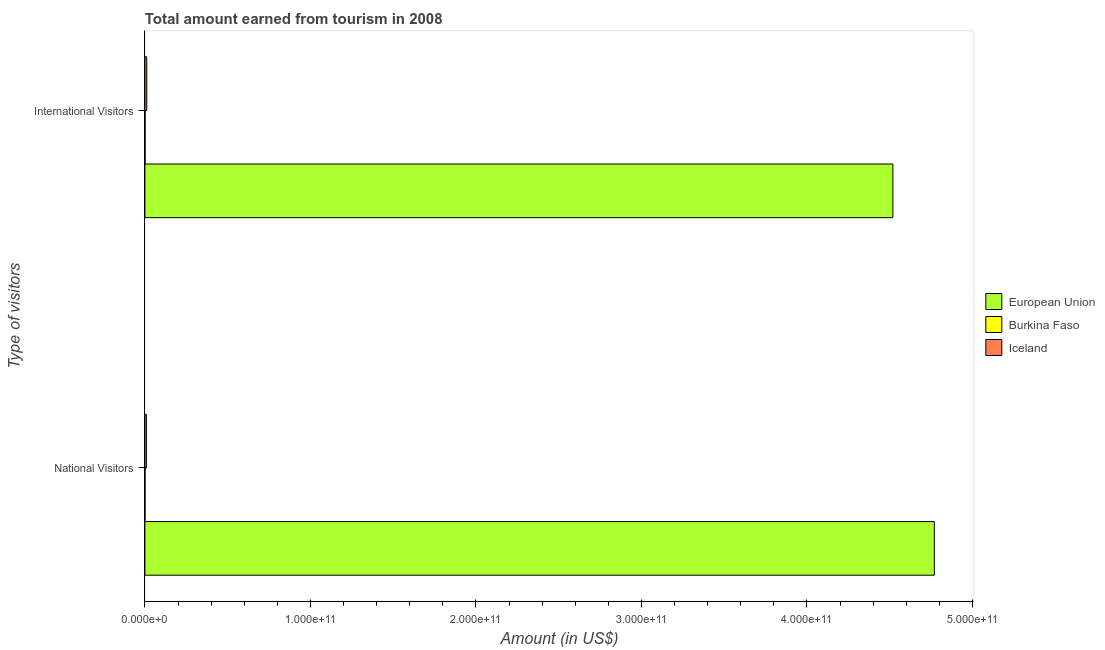Are the number of bars on each tick of the Y-axis equal?
Your response must be concise. Yes. What is the label of the 1st group of bars from the top?
Make the answer very short. International Visitors. What is the amount earned from international visitors in Burkina Faso?
Your response must be concise. 1.10e+08. Across all countries, what is the maximum amount earned from national visitors?
Keep it short and to the point. 4.77e+11. Across all countries, what is the minimum amount earned from international visitors?
Ensure brevity in your answer.  1.10e+08. In which country was the amount earned from national visitors maximum?
Offer a terse response. European Union. In which country was the amount earned from national visitors minimum?
Provide a succinct answer. Burkina Faso. What is the total amount earned from international visitors in the graph?
Your response must be concise. 4.53e+11. What is the difference between the amount earned from national visitors in European Union and that in Iceland?
Your answer should be compact. 4.76e+11. What is the difference between the amount earned from national visitors in European Union and the amount earned from international visitors in Burkina Faso?
Provide a succinct answer. 4.77e+11. What is the average amount earned from national visitors per country?
Give a very brief answer. 1.59e+11. What is the difference between the amount earned from national visitors and amount earned from international visitors in Iceland?
Your answer should be very brief. -2.22e+08. In how many countries, is the amount earned from international visitors greater than 320000000000 US$?
Offer a terse response. 1. What is the ratio of the amount earned from international visitors in Burkina Faso to that in European Union?
Offer a very short reply. 0. In how many countries, is the amount earned from international visitors greater than the average amount earned from international visitors taken over all countries?
Provide a short and direct response. 1. What does the 2nd bar from the top in International Visitors represents?
Provide a short and direct response. Burkina Faso. What does the 3rd bar from the bottom in National Visitors represents?
Offer a very short reply. Iceland. How many bars are there?
Keep it short and to the point. 6. How many countries are there in the graph?
Make the answer very short. 3. What is the difference between two consecutive major ticks on the X-axis?
Your answer should be very brief. 1.00e+11. Does the graph contain any zero values?
Offer a terse response. No. Where does the legend appear in the graph?
Provide a short and direct response. Center right. What is the title of the graph?
Make the answer very short. Total amount earned from tourism in 2008. What is the label or title of the Y-axis?
Provide a short and direct response. Type of visitors. What is the Amount (in US$) of European Union in National Visitors?
Ensure brevity in your answer.  4.77e+11. What is the Amount (in US$) in Burkina Faso in National Visitors?
Your answer should be very brief. 8.20e+07. What is the Amount (in US$) of Iceland in National Visitors?
Provide a succinct answer. 8.81e+08. What is the Amount (in US$) of European Union in International Visitors?
Ensure brevity in your answer.  4.52e+11. What is the Amount (in US$) of Burkina Faso in International Visitors?
Provide a succinct answer. 1.10e+08. What is the Amount (in US$) in Iceland in International Visitors?
Provide a succinct answer. 1.10e+09. Across all Type of visitors, what is the maximum Amount (in US$) in European Union?
Give a very brief answer. 4.77e+11. Across all Type of visitors, what is the maximum Amount (in US$) of Burkina Faso?
Offer a very short reply. 1.10e+08. Across all Type of visitors, what is the maximum Amount (in US$) in Iceland?
Provide a succinct answer. 1.10e+09. Across all Type of visitors, what is the minimum Amount (in US$) of European Union?
Your answer should be compact. 4.52e+11. Across all Type of visitors, what is the minimum Amount (in US$) in Burkina Faso?
Your response must be concise. 8.20e+07. Across all Type of visitors, what is the minimum Amount (in US$) of Iceland?
Make the answer very short. 8.81e+08. What is the total Amount (in US$) of European Union in the graph?
Your answer should be compact. 9.29e+11. What is the total Amount (in US$) in Burkina Faso in the graph?
Ensure brevity in your answer.  1.92e+08. What is the total Amount (in US$) in Iceland in the graph?
Offer a very short reply. 1.98e+09. What is the difference between the Amount (in US$) in European Union in National Visitors and that in International Visitors?
Your answer should be compact. 2.51e+1. What is the difference between the Amount (in US$) in Burkina Faso in National Visitors and that in International Visitors?
Your answer should be compact. -2.80e+07. What is the difference between the Amount (in US$) of Iceland in National Visitors and that in International Visitors?
Provide a succinct answer. -2.22e+08. What is the difference between the Amount (in US$) in European Union in National Visitors and the Amount (in US$) in Burkina Faso in International Visitors?
Your response must be concise. 4.77e+11. What is the difference between the Amount (in US$) of European Union in National Visitors and the Amount (in US$) of Iceland in International Visitors?
Your response must be concise. 4.76e+11. What is the difference between the Amount (in US$) in Burkina Faso in National Visitors and the Amount (in US$) in Iceland in International Visitors?
Your answer should be very brief. -1.02e+09. What is the average Amount (in US$) in European Union per Type of visitors?
Ensure brevity in your answer.  4.64e+11. What is the average Amount (in US$) of Burkina Faso per Type of visitors?
Ensure brevity in your answer.  9.60e+07. What is the average Amount (in US$) of Iceland per Type of visitors?
Offer a very short reply. 9.92e+08. What is the difference between the Amount (in US$) of European Union and Amount (in US$) of Burkina Faso in National Visitors?
Make the answer very short. 4.77e+11. What is the difference between the Amount (in US$) of European Union and Amount (in US$) of Iceland in National Visitors?
Offer a very short reply. 4.76e+11. What is the difference between the Amount (in US$) in Burkina Faso and Amount (in US$) in Iceland in National Visitors?
Keep it short and to the point. -7.99e+08. What is the difference between the Amount (in US$) of European Union and Amount (in US$) of Burkina Faso in International Visitors?
Your response must be concise. 4.52e+11. What is the difference between the Amount (in US$) of European Union and Amount (in US$) of Iceland in International Visitors?
Make the answer very short. 4.51e+11. What is the difference between the Amount (in US$) of Burkina Faso and Amount (in US$) of Iceland in International Visitors?
Your answer should be compact. -9.93e+08. What is the ratio of the Amount (in US$) of European Union in National Visitors to that in International Visitors?
Keep it short and to the point. 1.06. What is the ratio of the Amount (in US$) of Burkina Faso in National Visitors to that in International Visitors?
Keep it short and to the point. 0.75. What is the ratio of the Amount (in US$) of Iceland in National Visitors to that in International Visitors?
Offer a very short reply. 0.8. What is the difference between the highest and the second highest Amount (in US$) of European Union?
Your answer should be very brief. 2.51e+1. What is the difference between the highest and the second highest Amount (in US$) in Burkina Faso?
Provide a short and direct response. 2.80e+07. What is the difference between the highest and the second highest Amount (in US$) of Iceland?
Keep it short and to the point. 2.22e+08. What is the difference between the highest and the lowest Amount (in US$) of European Union?
Ensure brevity in your answer.  2.51e+1. What is the difference between the highest and the lowest Amount (in US$) of Burkina Faso?
Keep it short and to the point. 2.80e+07. What is the difference between the highest and the lowest Amount (in US$) of Iceland?
Offer a terse response. 2.22e+08. 